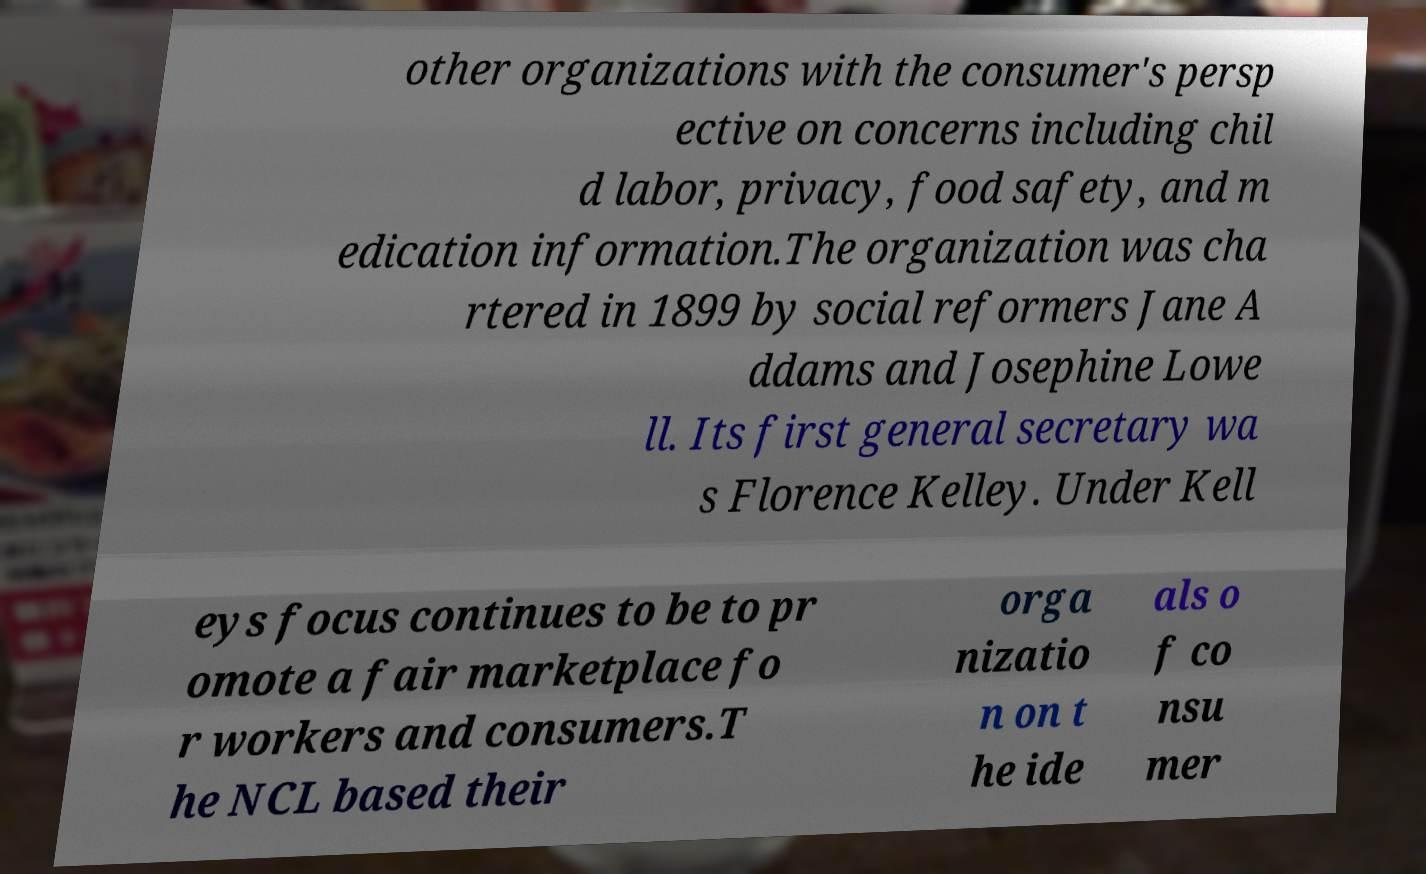What messages or text are displayed in this image? I need them in a readable, typed format. other organizations with the consumer's persp ective on concerns including chil d labor, privacy, food safety, and m edication information.The organization was cha rtered in 1899 by social reformers Jane A ddams and Josephine Lowe ll. Its first general secretary wa s Florence Kelley. Under Kell eys focus continues to be to pr omote a fair marketplace fo r workers and consumers.T he NCL based their orga nizatio n on t he ide als o f co nsu mer 